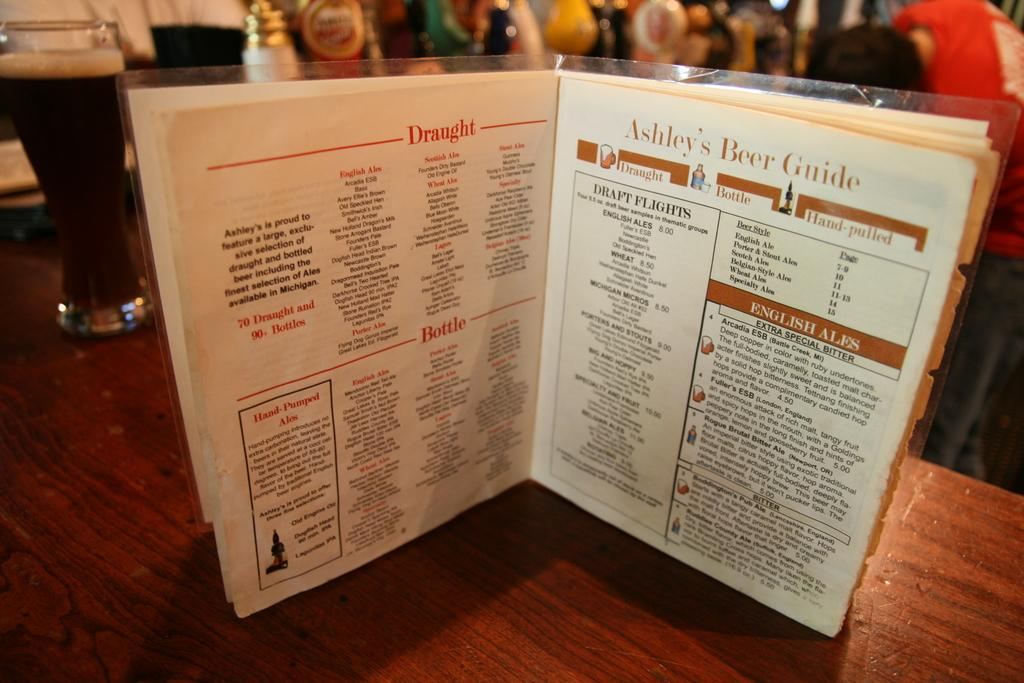<image>
Offer a succinct explanation of the picture presented. Ashley's Beer guide that contains English Ales and draft flights. 